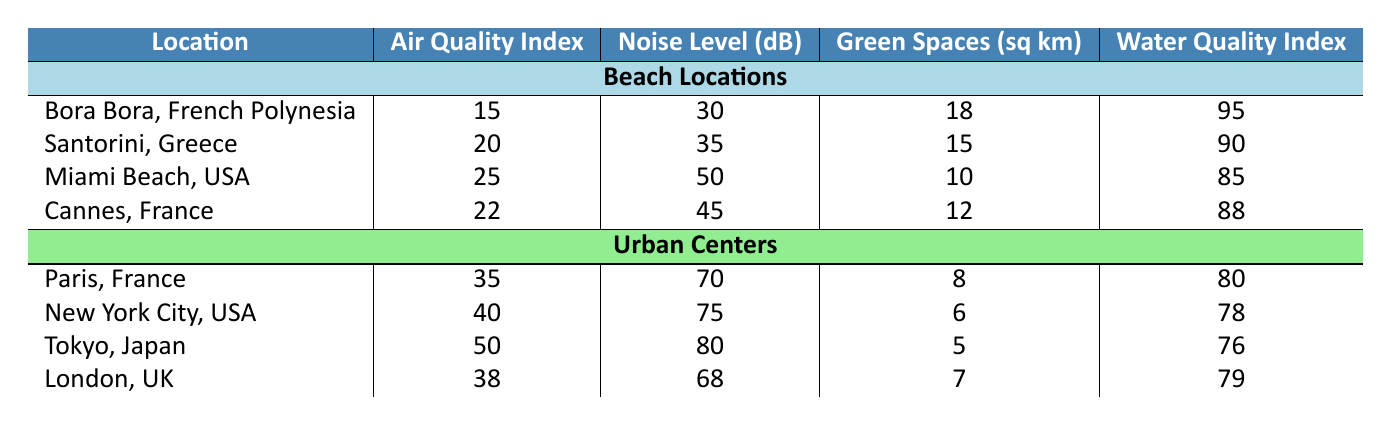What is the Air Quality Index of Bora Bora? The Air Quality Index for Bora Bora is provided directly in the table under the corresponding row, which shows a value of 15.
Answer: 15 What is the average Noise Level for all the urban centers listed? The Noise Levels for the urban centers are 70 (Paris), 75 (New York City), 80 (Tokyo), and 68 (London). The sum of these values is 70 + 75 + 80 + 68 = 293. There are 4 urban centers, so the average is 293 / 4 = 73.25.
Answer: 73.25 Is the Water Quality Index higher for the beach or urban locations? The highest Water Quality Index for beaches is 95 (Bora Bora), whereas the highest for urban centers is 80 (Paris). Since 95 is greater than 80, the Water Quality Index is higher for beach locations.
Answer: Yes Which location has the least available green spaces? From the table, the available green spaces for urban centers are 8 (Paris), 6 (New York City), 5 (Tokyo), and 7 (London). The beach locations have 18 (Bora Bora), 15 (Santorini), 10 (Miami Beach), and 12 (Cannes). The least available green spaces are found in New York City with 6 sq km.
Answer: New York City What is the difference in the Air Quality Index between the best and worst beach locations? The best Air Quality Index among beach locations is 15 (Bora Bora), and the worst is 25 (Miami Beach). To find the difference, we calculate 25 - 15 = 10.
Answer: 10 What is the total number of available green spaces for all beach locations? The available green spaces for the beach locations are 18 (Bora Bora), 15 (Santorini), 10 (Miami Beach), and 12 (Cannes). Adding these together gives 18 + 15 + 10 + 12 = 55 sq km.
Answer: 55 Is the Noise Level for Santorini higher or lower than that for Cannes? The Noise Level for Santorini is 35 dB, while for Cannes it is 45 dB. Since 35 is less than 45, the Noise Level for Santorini is lower.
Answer: Lower Does Tokyo have a lower Water Quality Index than Miami Beach? The Water Quality Index for Tokyo is 76, while Miami Beach has a Water Quality Index of 85. Since 76 is less than 85, Tokyo does have a lower Water Quality Index than Miami Beach.
Answer: Yes What is the average Air Quality Index of the beach locations? The Air Quality Index for beach locations is 15 (Bora Bora), 20 (Santorini), 25 (Miami Beach), and 22 (Cannes). Summing these gives 15 + 20 + 25 + 22 = 82. There are 4 beach locations, so the average is 82 / 4 = 20.5.
Answer: 20.5 